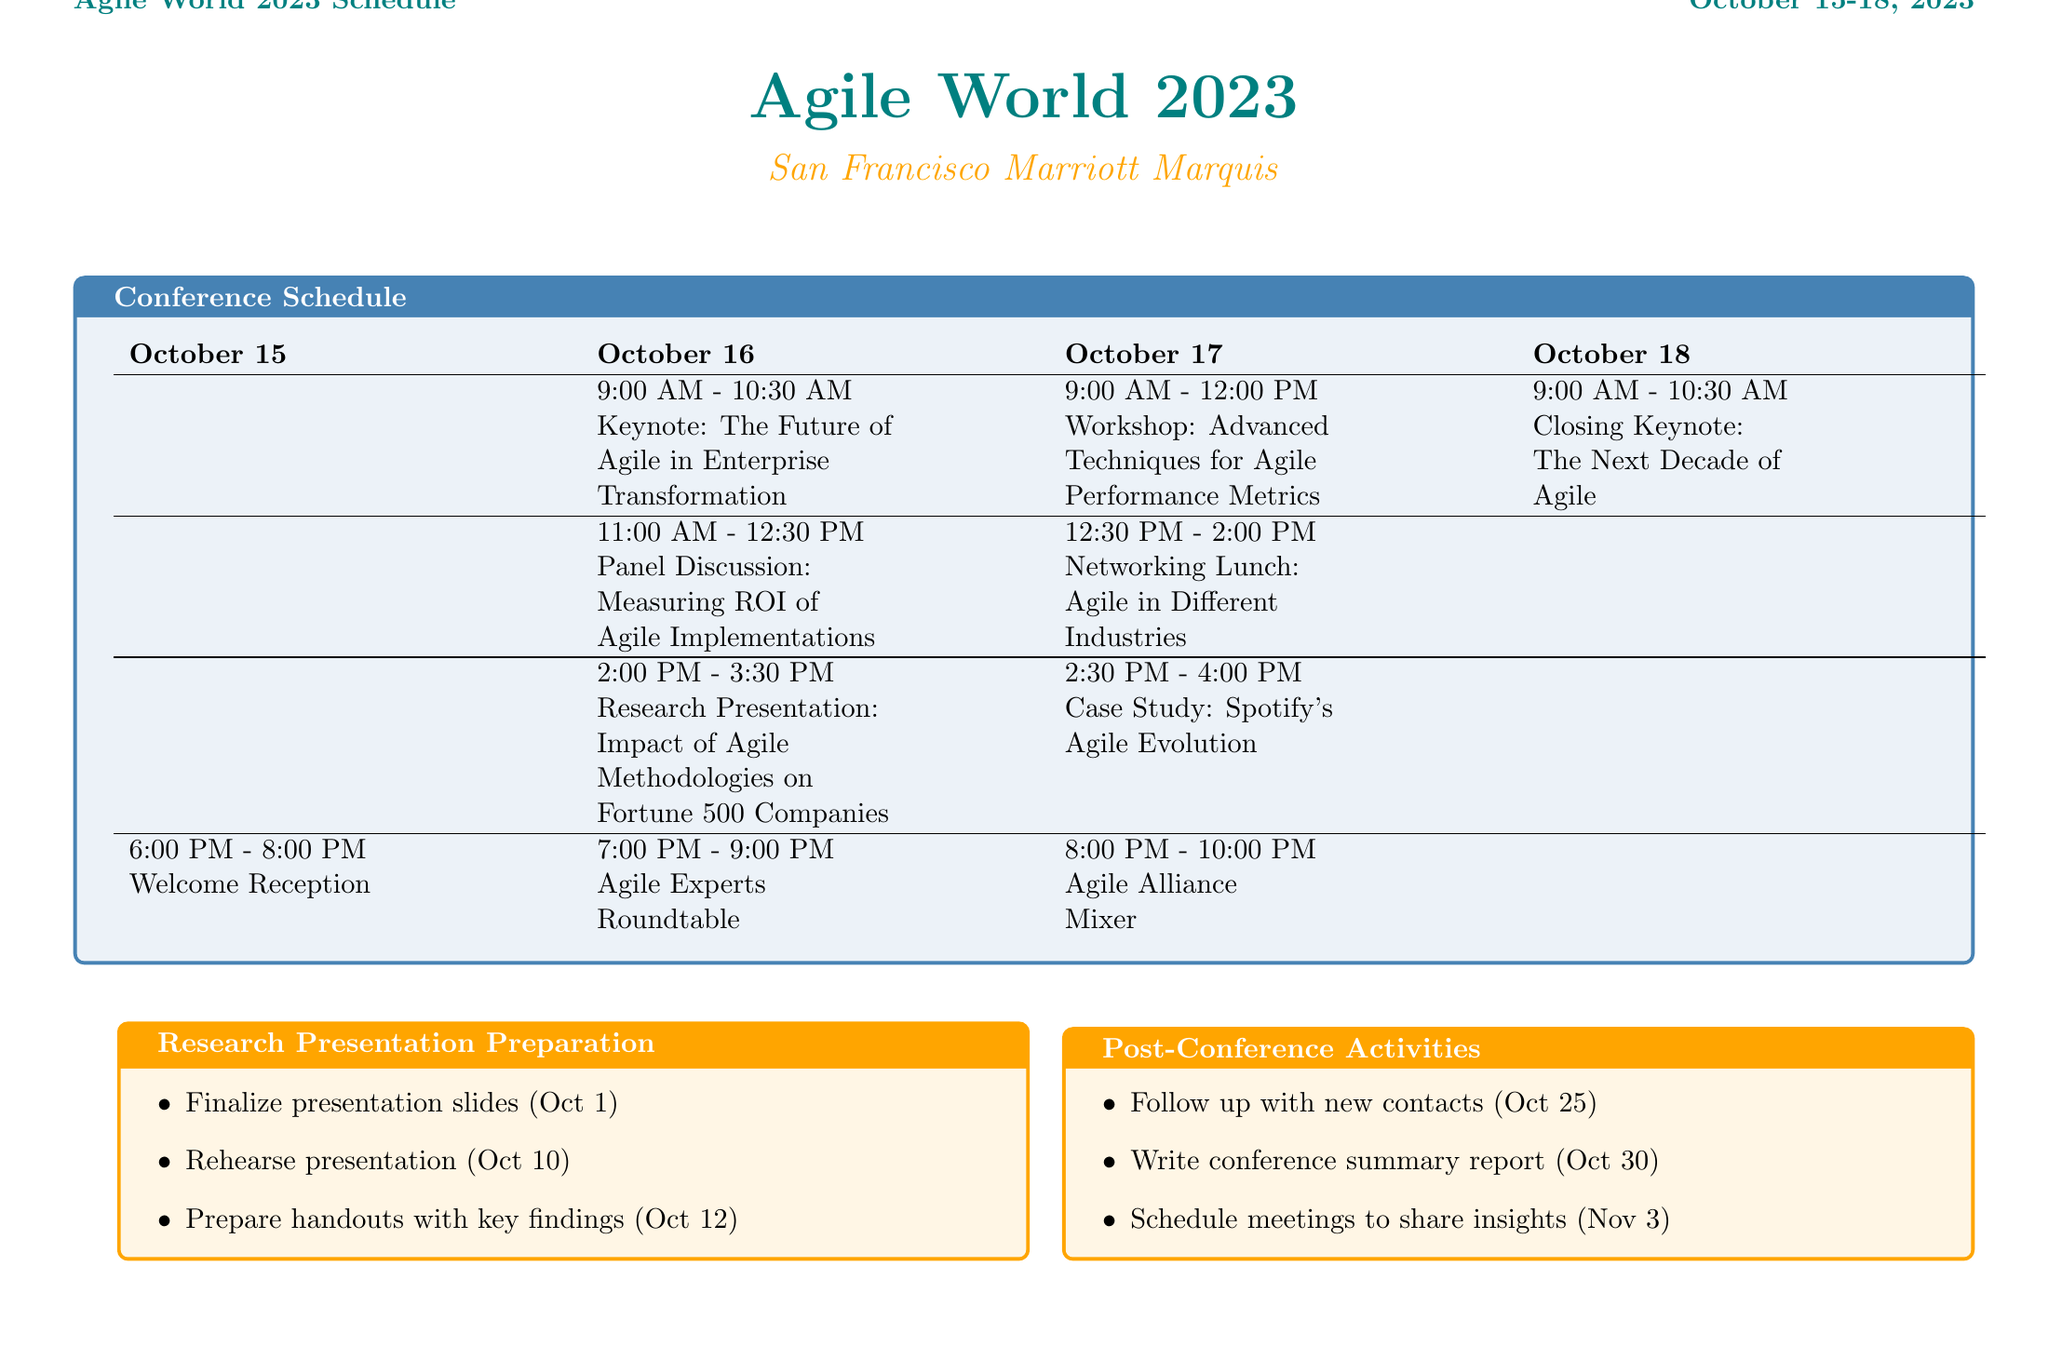What is the name of the conference? The conference name listed in the document is "Agile World 2023."
Answer: Agile World 2023 When does the keynote on the future of Agile take place? The document specifies that the keynote is scheduled for October 16, 2023, at 9:00 AM.
Answer: October 16, 2023 Who is the presenter of the research presentation? The document indicates that the presenter of the research presentation is identified as "Your Name, Technology Analyst."
Answer: Your Name, Technology Analyst What time is the Networking Lunch on October 17? According to the schedule, the Networking Lunch is from 12:30 PM to 2:00 PM on October 17, 2023.
Answer: 12:30 PM - 2:00 PM Which session follows the Research Presentation on October 16? The document states that the session following the Research Presentation is the Case Study on Spotify's Agile Evolution, scheduled from 2:30 PM to 4:00 PM.
Answer: Case Study: Spotify's Agile Evolution What is the deadline for preparing handouts with key findings? The schedule outlines that the deadline for preparing handouts with key findings is October 12, 2023.
Answer: October 12, 2023 Where is the Agile Experts Roundtable being held? The document specifies that the Agile Experts Roundtable will take place in the Golden Gate Hall.
Answer: Golden Gate Hall When is the follow-up with new contacts due? The follow-up with new contacts is due on October 25, 2023, as indicated in the post-conference activities section.
Answer: October 25, 2023 Who is the speaker for the closing keynote? The closing keynote speaker mentioned in the document is Martin Fowler, the Chief Scientist at ThoughtWorks.
Answer: Martin Fowler 